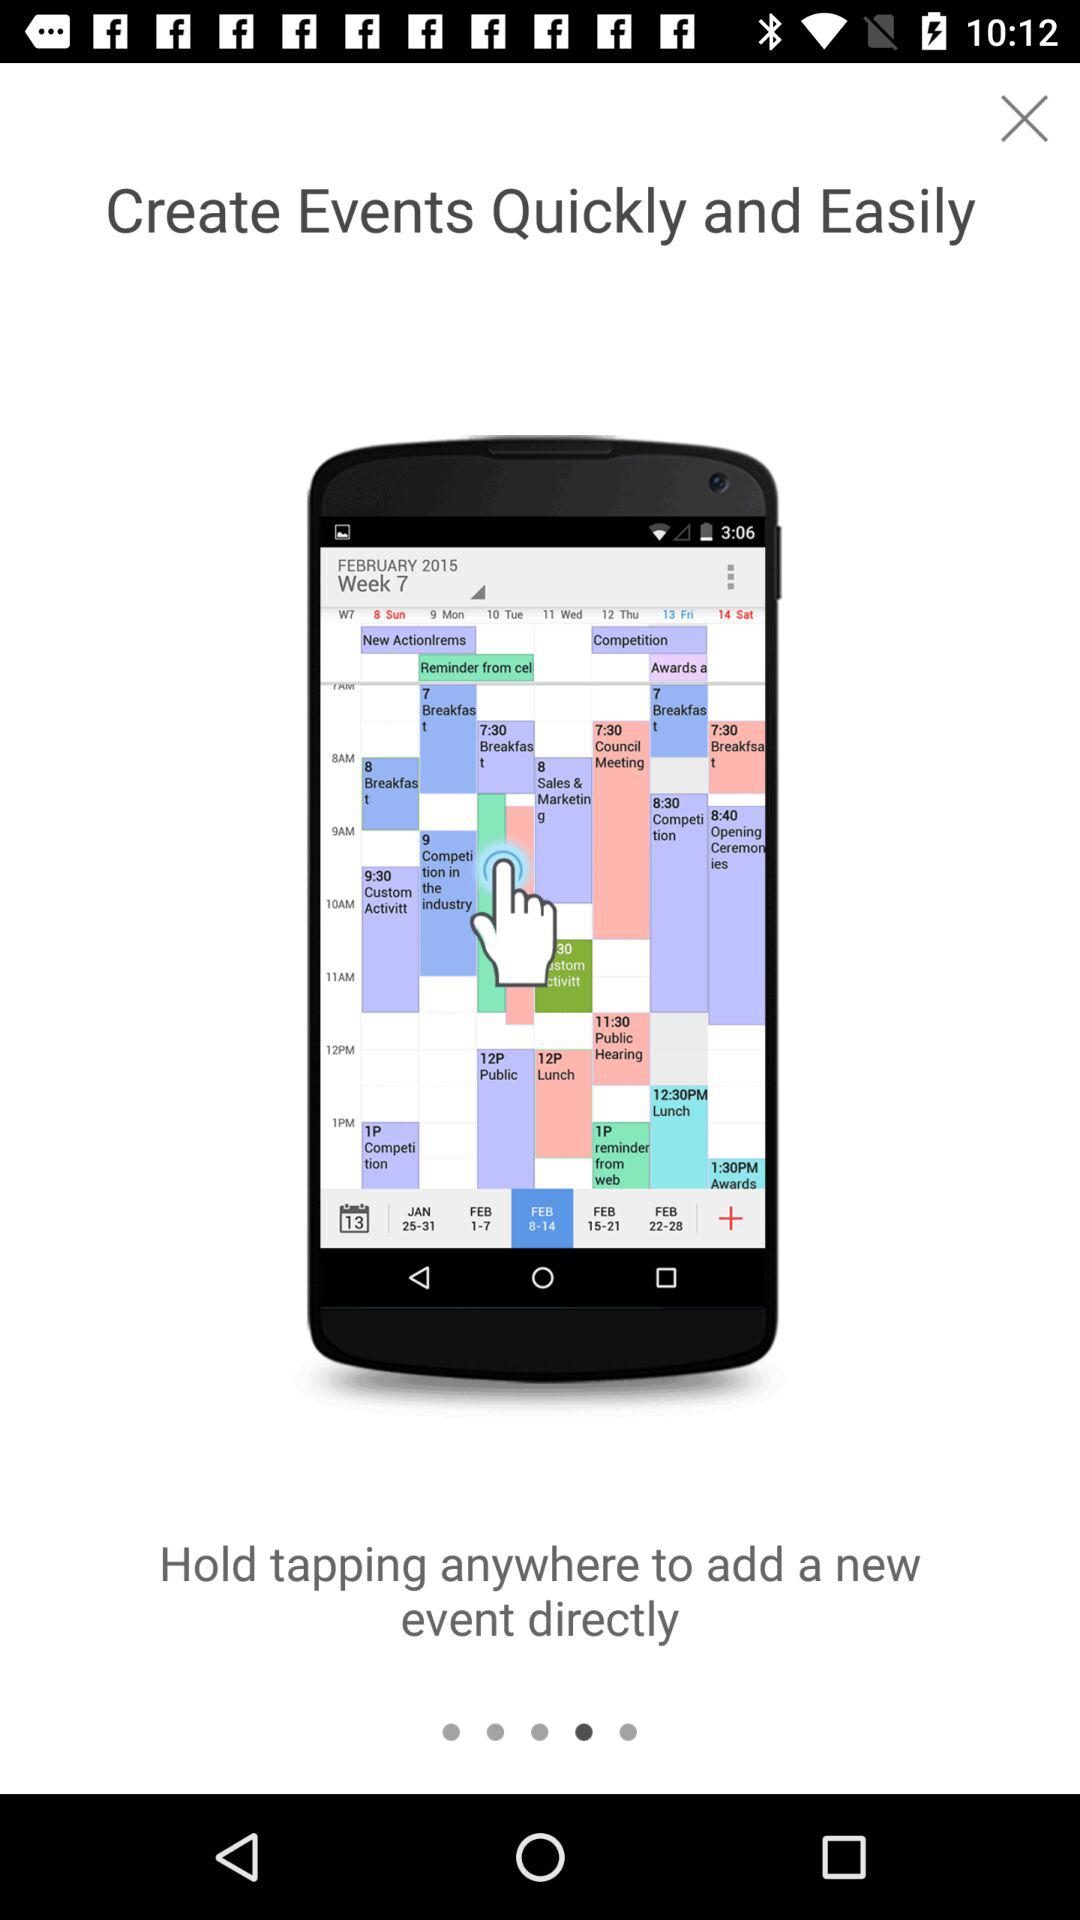Which date range is selected? The selected date range is from February 8 to February14, 2015. 